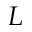Convert formula to latex. <formula><loc_0><loc_0><loc_500><loc_500>L</formula> 